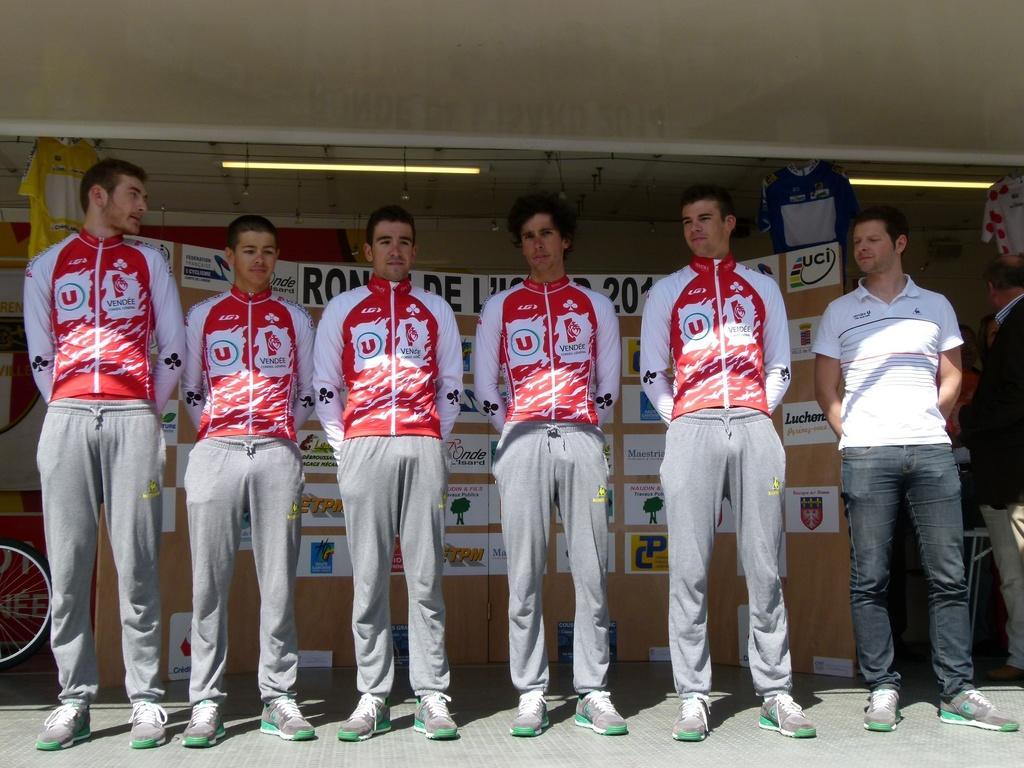What logo is on the shirt?
Ensure brevity in your answer.  Vendee. 